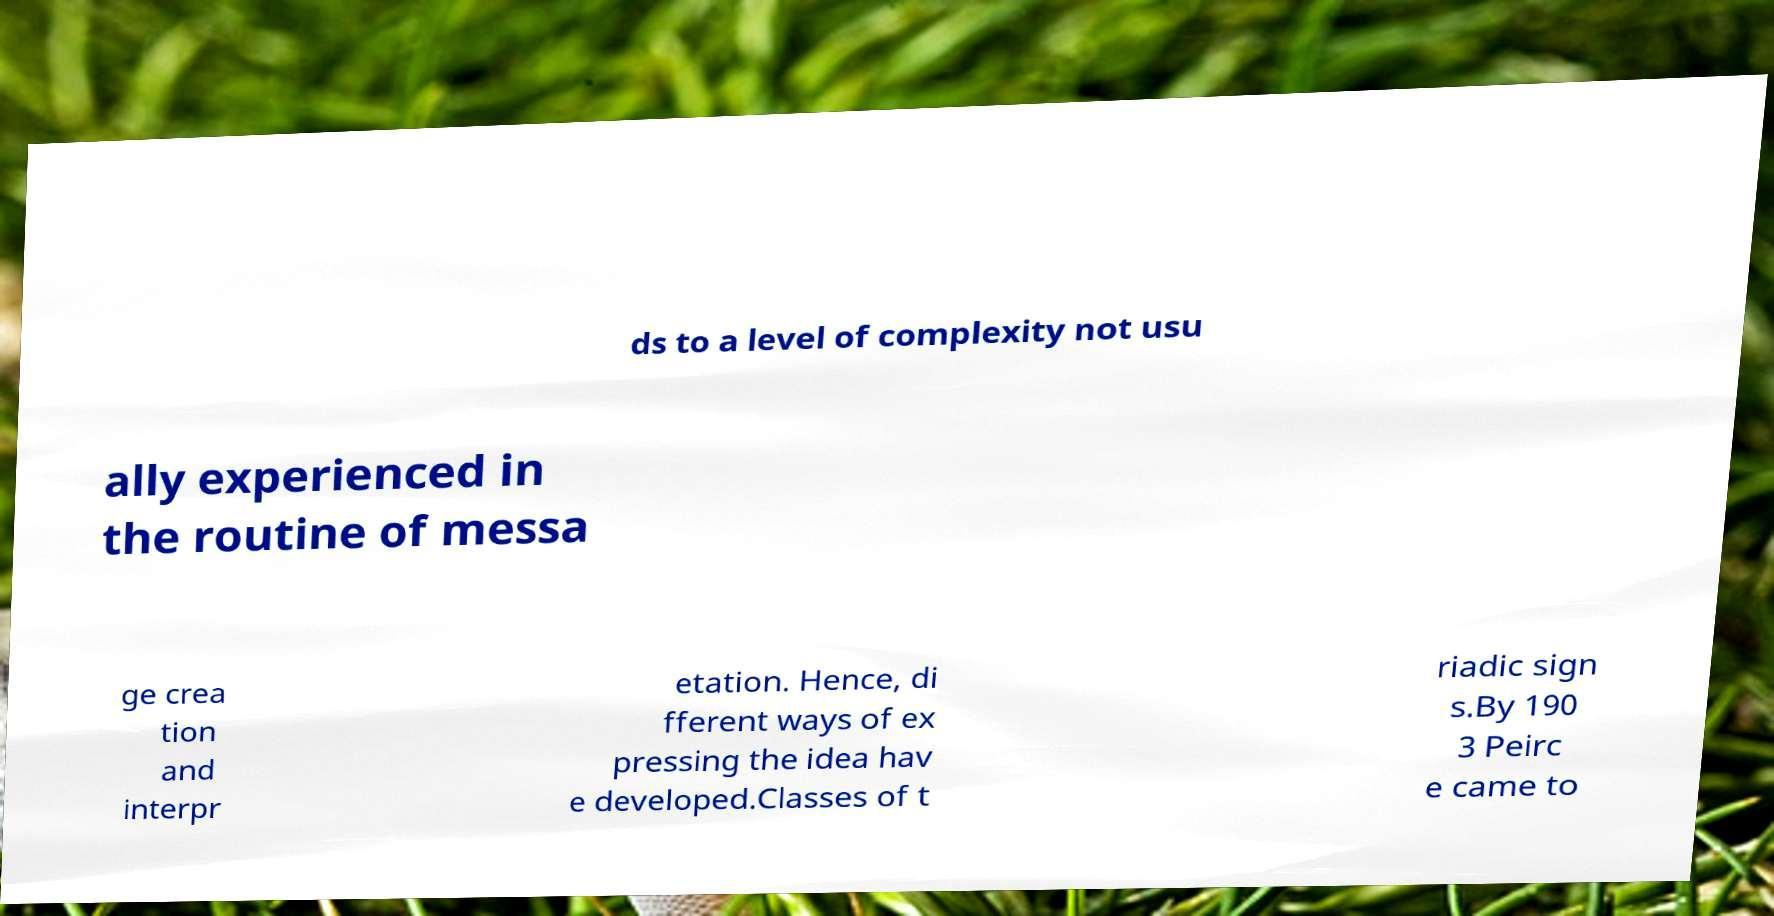Please identify and transcribe the text found in this image. ds to a level of complexity not usu ally experienced in the routine of messa ge crea tion and interpr etation. Hence, di fferent ways of ex pressing the idea hav e developed.Classes of t riadic sign s.By 190 3 Peirc e came to 